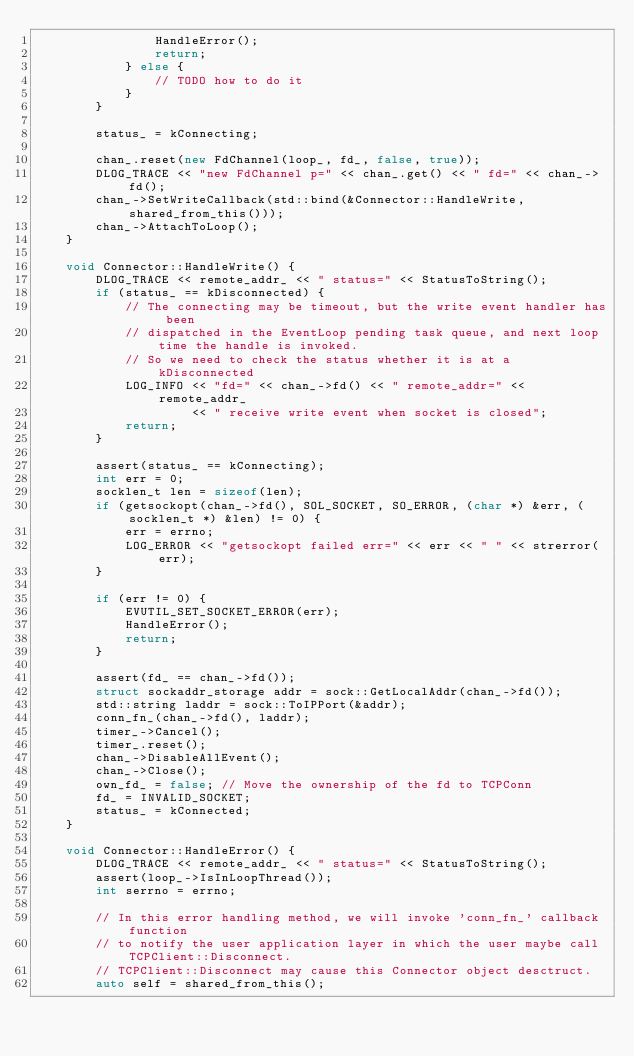<code> <loc_0><loc_0><loc_500><loc_500><_C++_>                HandleError();
                return;
            } else {
                // TODO how to do it
            }
        }

        status_ = kConnecting;

        chan_.reset(new FdChannel(loop_, fd_, false, true));
        DLOG_TRACE << "new FdChannel p=" << chan_.get() << " fd=" << chan_->fd();
        chan_->SetWriteCallback(std::bind(&Connector::HandleWrite, shared_from_this()));
        chan_->AttachToLoop();
    }

    void Connector::HandleWrite() {
        DLOG_TRACE << remote_addr_ << " status=" << StatusToString();
        if (status_ == kDisconnected) {
            // The connecting may be timeout, but the write event handler has been
            // dispatched in the EventLoop pending task queue, and next loop time the handle is invoked.
            // So we need to check the status whether it is at a kDisconnected
            LOG_INFO << "fd=" << chan_->fd() << " remote_addr=" << remote_addr_
                     << " receive write event when socket is closed";
            return;
        }

        assert(status_ == kConnecting);
        int err = 0;
        socklen_t len = sizeof(len);
        if (getsockopt(chan_->fd(), SOL_SOCKET, SO_ERROR, (char *) &err, (socklen_t *) &len) != 0) {
            err = errno;
            LOG_ERROR << "getsockopt failed err=" << err << " " << strerror(err);
        }

        if (err != 0) {
            EVUTIL_SET_SOCKET_ERROR(err);
            HandleError();
            return;
        }

        assert(fd_ == chan_->fd());
        struct sockaddr_storage addr = sock::GetLocalAddr(chan_->fd());
        std::string laddr = sock::ToIPPort(&addr);
        conn_fn_(chan_->fd(), laddr);
        timer_->Cancel();
        timer_.reset();
        chan_->DisableAllEvent();
        chan_->Close();
        own_fd_ = false; // Move the ownership of the fd to TCPConn
        fd_ = INVALID_SOCKET;
        status_ = kConnected;
    }

    void Connector::HandleError() {
        DLOG_TRACE << remote_addr_ << " status=" << StatusToString();
        assert(loop_->IsInLoopThread());
        int serrno = errno;

        // In this error handling method, we will invoke 'conn_fn_' callback function
        // to notify the user application layer in which the user maybe call TCPClient::Disconnect.
        // TCPClient::Disconnect may cause this Connector object desctruct.
        auto self = shared_from_this();
</code> 